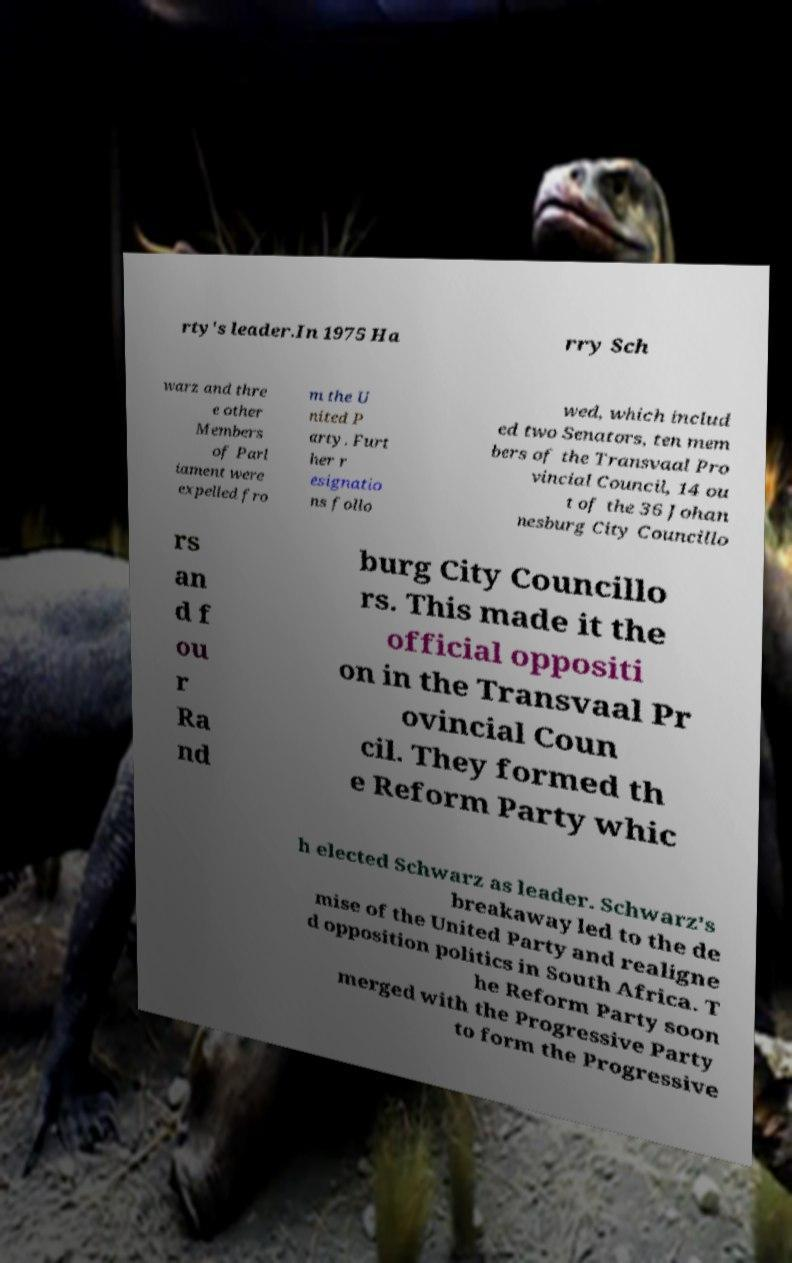For documentation purposes, I need the text within this image transcribed. Could you provide that? rty's leader.In 1975 Ha rry Sch warz and thre e other Members of Parl iament were expelled fro m the U nited P arty. Furt her r esignatio ns follo wed, which includ ed two Senators, ten mem bers of the Transvaal Pro vincial Council, 14 ou t of the 36 Johan nesburg City Councillo rs an d f ou r Ra nd burg City Councillo rs. This made it the official oppositi on in the Transvaal Pr ovincial Coun cil. They formed th e Reform Party whic h elected Schwarz as leader. Schwarz's breakaway led to the de mise of the United Party and realigne d opposition politics in South Africa. T he Reform Party soon merged with the Progressive Party to form the Progressive 